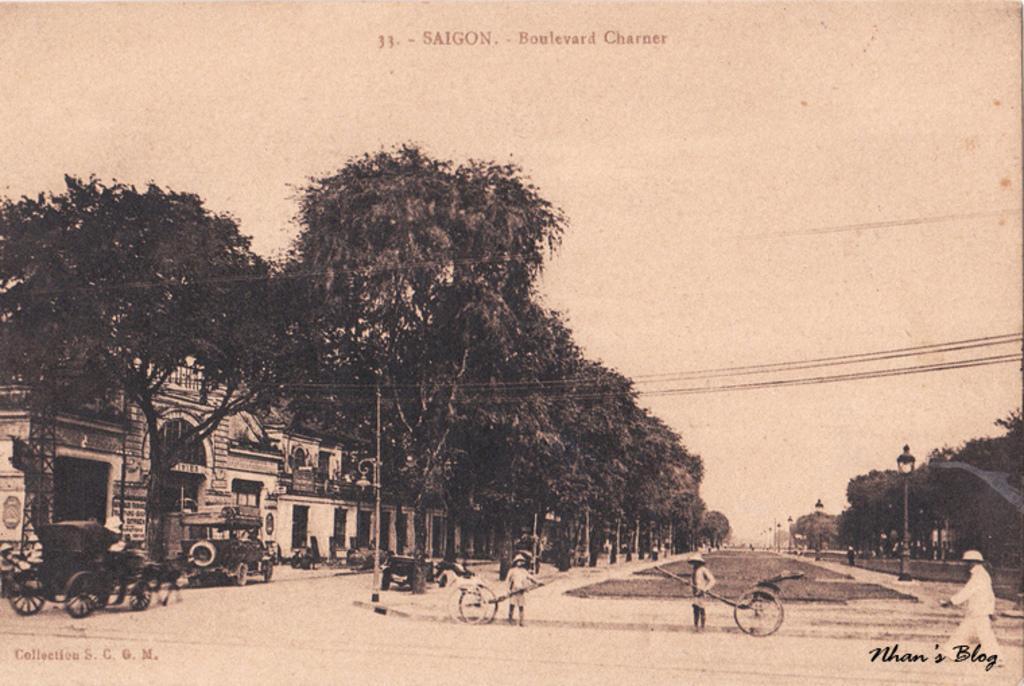In one or two sentences, can you explain what this image depicts? In this picture we can see few people are walking, we can see some vehicles are on the road, side we can see some buildings, trees. 